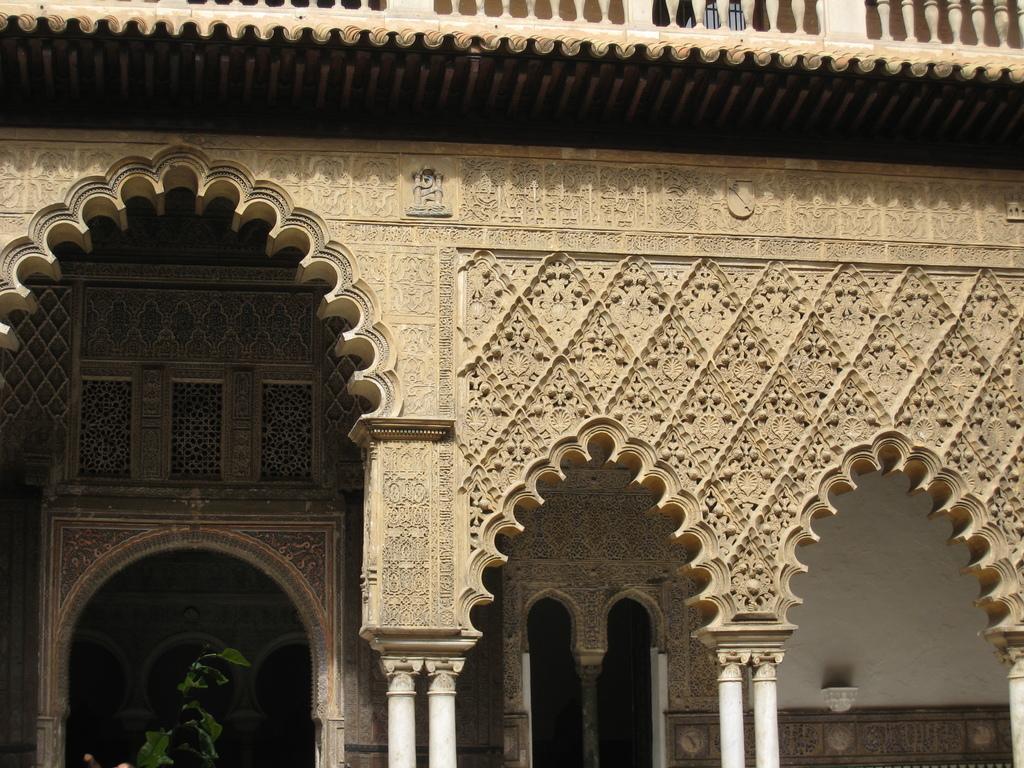Please provide a concise description of this image. In the picture I can see a building, pillars, wall, fence and art design on the building. 